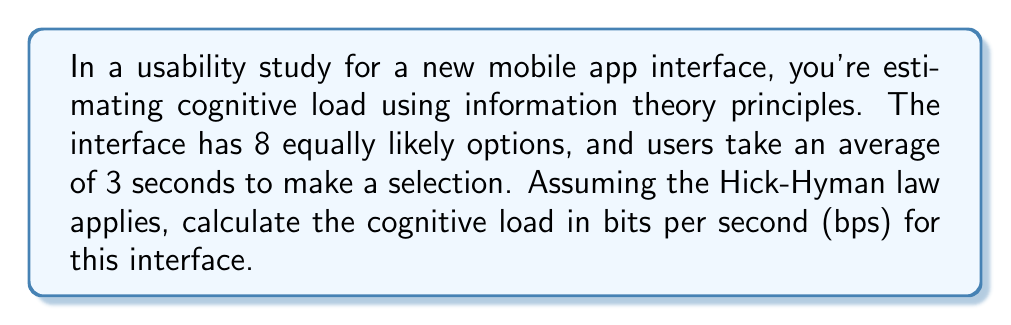Provide a solution to this math problem. To solve this problem, we'll use the Hick-Hyman law and information theory principles. Here's a step-by-step approach:

1. The Hick-Hyman law states that the time $T$ it takes to make a decision is proportional to the amount of information $H$ processed:

   $T = a + b \cdot H$

   Where $a$ is the initial delay, $b$ is the rate of gain of information, and $H$ is the information content.

2. In this case, we have 8 equally likely options. The information content $H$ is calculated using Shannon's entropy formula:

   $H = -\sum_{i=1}^n p_i \log_2(p_i)$

   Where $p_i$ is the probability of each option.

3. For 8 equally likely options, $p_i = \frac{1}{8}$ for all $i$. So:

   $H = -8 \cdot (\frac{1}{8} \log_2(\frac{1}{8})) = -8 \cdot (\frac{1}{8} \cdot (-3)) = 3$ bits

4. We know that $T = 3$ seconds and $H = 3$ bits. Assuming $a = 0$ for simplicity, we can calculate $b$:

   $3 = 0 + b \cdot 3$
   $b = 1$ second/bit

5. The cognitive load is the rate at which information is processed, which is the inverse of $b$:

   Cognitive Load = $\frac{1}{b} = \frac{1}{1} = 1$ bit/second

Thus, the cognitive load for this interface is 1 bit per second (bps).
Answer: 1 bps 